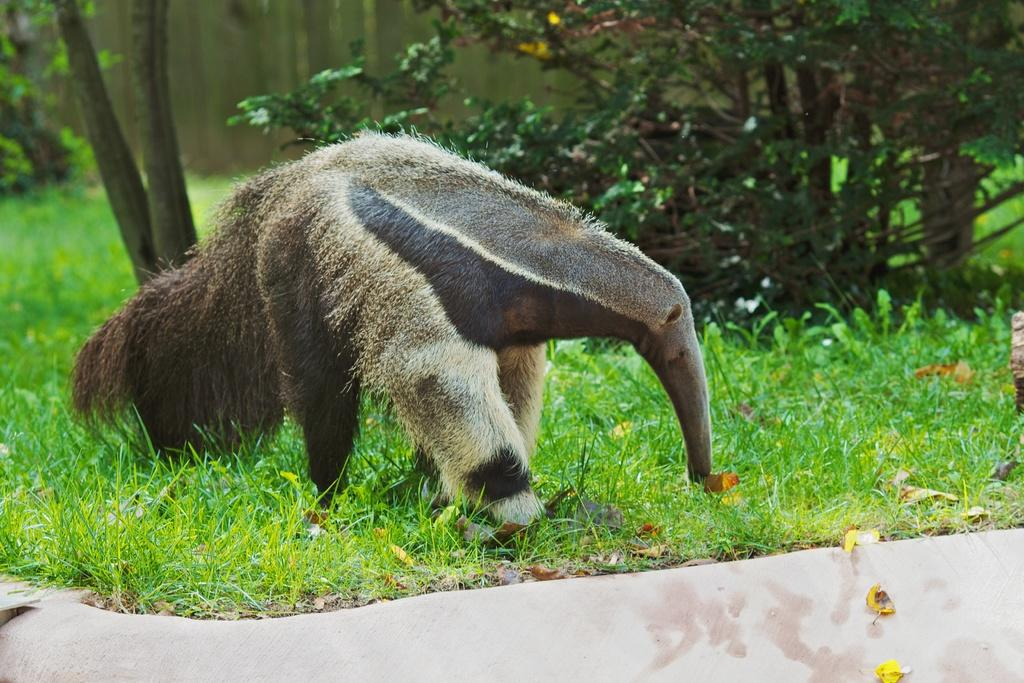What type of animal can be seen in the image? There is an animal in the image, but its specific type cannot be determined from the provided facts. What is the animal doing in the image? The animal is grazing the grass. What type of vegetation is visible in the image? There are trees and grass visible in the image. What type of toothbrush is the animal using to brush its teeth in the image? There is no toothbrush or indication of teeth brushing in the image. How much milk is the animal drinking in the image? There is no milk or drinking activity depicted in the image. 